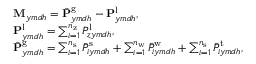Convert formula to latex. <formula><loc_0><loc_0><loc_500><loc_500>\begin{array} { r l } & { M _ { y m d h } = \bar { P } _ { y m d h } ^ { g } - { P } _ { y m d h } ^ { l } , } \\ & { P _ { y m d h } ^ { l } = \sum _ { i = 1 } ^ { n _ { z } } { P } _ { z y m d h } ^ { l } , } \\ & { \bar { P } _ { y m d h } ^ { g } = \sum _ { i = 1 } ^ { n _ { s } } \bar { P } _ { i y m d h } ^ { s } + \sum _ { i = 1 } ^ { n _ { w } } \bar { P } _ { i y m d h } ^ { w } + \sum _ { i = 1 } ^ { n _ { s } } \bar { P } _ { i y m d h } ^ { t } , } \end{array}</formula> 